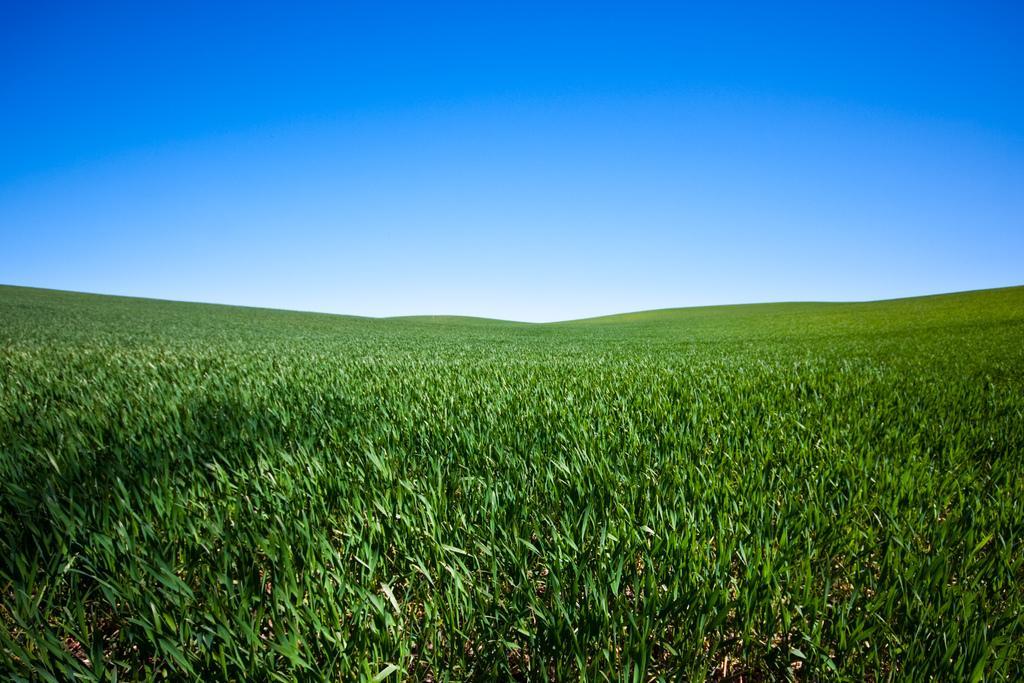Please provide a concise description of this image. In this image at the bottom there are some plants, and on the top of the image there is sky. 